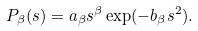<formula> <loc_0><loc_0><loc_500><loc_500>P _ { \beta } ( s ) = a _ { \beta } s ^ { \beta } \exp ( - b _ { \beta } s ^ { 2 } ) .</formula> 